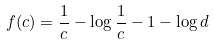Convert formula to latex. <formula><loc_0><loc_0><loc_500><loc_500>f ( c ) = \frac { 1 } { c } - \log \frac { 1 } { c } - 1 - \log d</formula> 